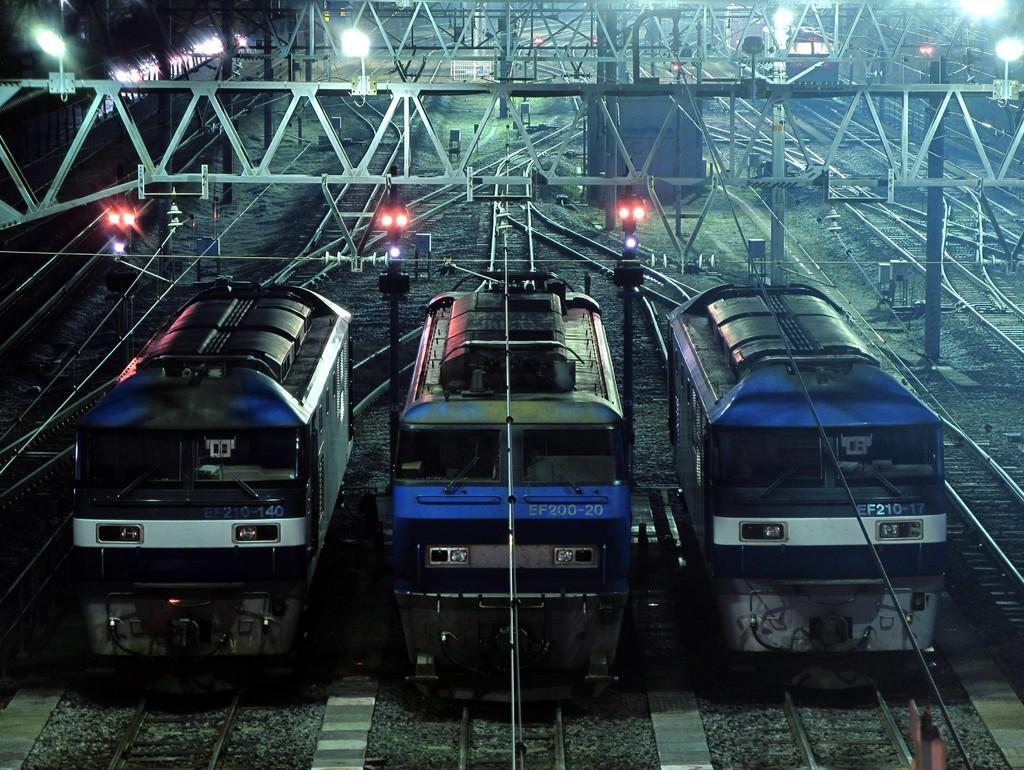In one or two sentences, can you explain what this image depicts? In this image we can see train engines. There are railway tracks, rods. To the left side of the image there is a train. There are light poles. 